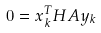Convert formula to latex. <formula><loc_0><loc_0><loc_500><loc_500>0 = x _ { k } ^ { T } H A y _ { k }</formula> 